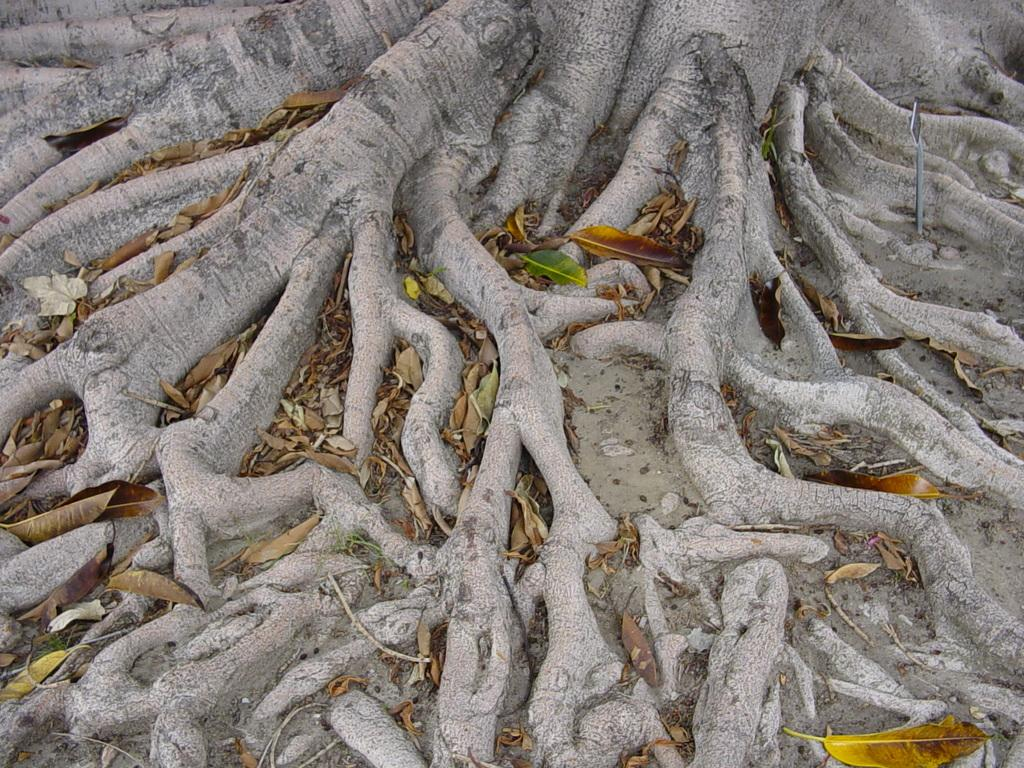What type of plant feature can be seen in the image? There are roots of a tree in the image. What type of plant debris is present on the surface in the image? There are dry leaves on the surface in the image. Where is the box located in the image? There is no box present in the image. 